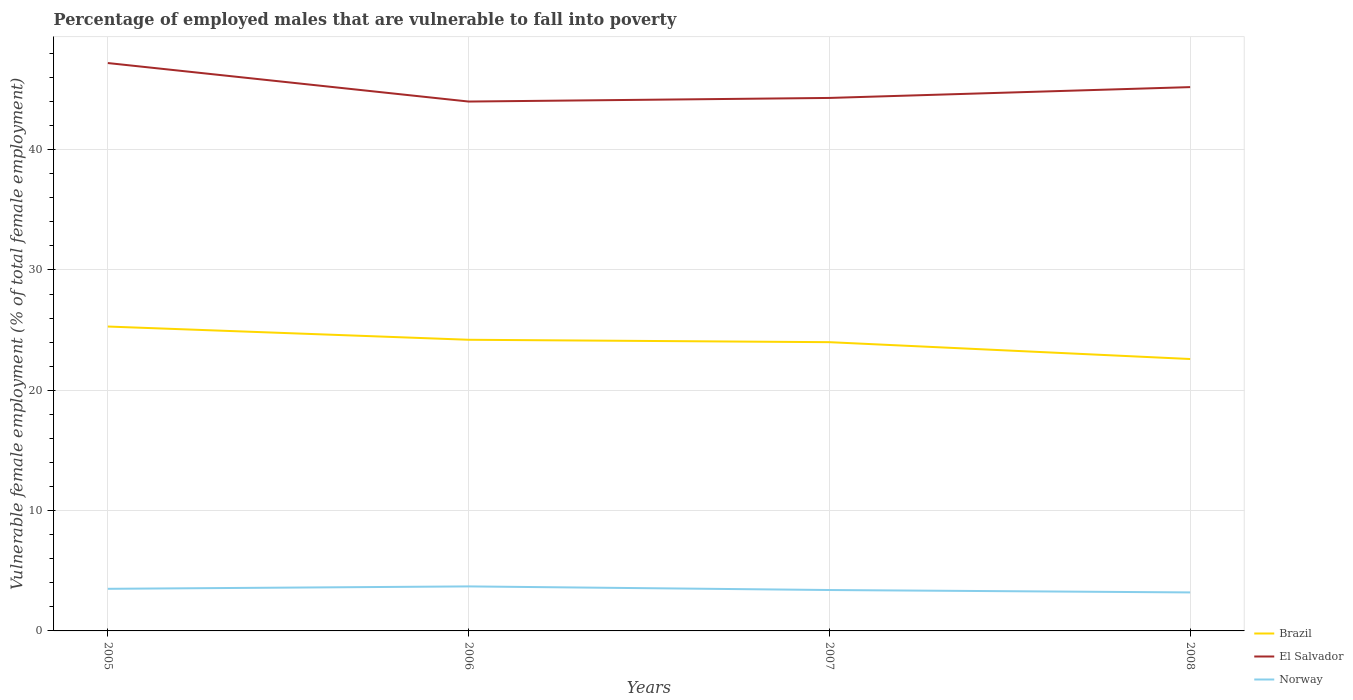How many different coloured lines are there?
Provide a short and direct response. 3. Is the number of lines equal to the number of legend labels?
Offer a very short reply. Yes. Across all years, what is the maximum percentage of employed males who are vulnerable to fall into poverty in Brazil?
Provide a succinct answer. 22.6. In which year was the percentage of employed males who are vulnerable to fall into poverty in Brazil maximum?
Provide a short and direct response. 2008. What is the total percentage of employed males who are vulnerable to fall into poverty in Brazil in the graph?
Your answer should be very brief. 1.6. What is the difference between the highest and the second highest percentage of employed males who are vulnerable to fall into poverty in Norway?
Offer a terse response. 0.5. What is the difference between the highest and the lowest percentage of employed males who are vulnerable to fall into poverty in El Salvador?
Your response must be concise. 2. Is the percentage of employed males who are vulnerable to fall into poverty in Brazil strictly greater than the percentage of employed males who are vulnerable to fall into poverty in Norway over the years?
Make the answer very short. No. How many lines are there?
Ensure brevity in your answer.  3. How many years are there in the graph?
Offer a terse response. 4. Does the graph contain any zero values?
Offer a very short reply. No. Does the graph contain grids?
Your answer should be very brief. Yes. How many legend labels are there?
Offer a terse response. 3. What is the title of the graph?
Your response must be concise. Percentage of employed males that are vulnerable to fall into poverty. Does "South Asia" appear as one of the legend labels in the graph?
Keep it short and to the point. No. What is the label or title of the X-axis?
Your answer should be compact. Years. What is the label or title of the Y-axis?
Your answer should be compact. Vulnerable female employment (% of total female employment). What is the Vulnerable female employment (% of total female employment) of Brazil in 2005?
Your answer should be compact. 25.3. What is the Vulnerable female employment (% of total female employment) in El Salvador in 2005?
Offer a very short reply. 47.2. What is the Vulnerable female employment (% of total female employment) of Brazil in 2006?
Provide a short and direct response. 24.2. What is the Vulnerable female employment (% of total female employment) of Norway in 2006?
Give a very brief answer. 3.7. What is the Vulnerable female employment (% of total female employment) of El Salvador in 2007?
Your response must be concise. 44.3. What is the Vulnerable female employment (% of total female employment) in Norway in 2007?
Keep it short and to the point. 3.4. What is the Vulnerable female employment (% of total female employment) of Brazil in 2008?
Provide a succinct answer. 22.6. What is the Vulnerable female employment (% of total female employment) of El Salvador in 2008?
Your answer should be compact. 45.2. What is the Vulnerable female employment (% of total female employment) of Norway in 2008?
Ensure brevity in your answer.  3.2. Across all years, what is the maximum Vulnerable female employment (% of total female employment) in Brazil?
Offer a terse response. 25.3. Across all years, what is the maximum Vulnerable female employment (% of total female employment) of El Salvador?
Your response must be concise. 47.2. Across all years, what is the maximum Vulnerable female employment (% of total female employment) of Norway?
Your answer should be compact. 3.7. Across all years, what is the minimum Vulnerable female employment (% of total female employment) of Brazil?
Provide a short and direct response. 22.6. Across all years, what is the minimum Vulnerable female employment (% of total female employment) of El Salvador?
Provide a succinct answer. 44. Across all years, what is the minimum Vulnerable female employment (% of total female employment) in Norway?
Offer a very short reply. 3.2. What is the total Vulnerable female employment (% of total female employment) of Brazil in the graph?
Ensure brevity in your answer.  96.1. What is the total Vulnerable female employment (% of total female employment) in El Salvador in the graph?
Keep it short and to the point. 180.7. What is the difference between the Vulnerable female employment (% of total female employment) in El Salvador in 2005 and that in 2006?
Give a very brief answer. 3.2. What is the difference between the Vulnerable female employment (% of total female employment) of Brazil in 2005 and that in 2007?
Keep it short and to the point. 1.3. What is the difference between the Vulnerable female employment (% of total female employment) in El Salvador in 2005 and that in 2007?
Provide a short and direct response. 2.9. What is the difference between the Vulnerable female employment (% of total female employment) of El Salvador in 2005 and that in 2008?
Keep it short and to the point. 2. What is the difference between the Vulnerable female employment (% of total female employment) in Brazil in 2006 and that in 2007?
Offer a terse response. 0.2. What is the difference between the Vulnerable female employment (% of total female employment) in Norway in 2006 and that in 2007?
Offer a very short reply. 0.3. What is the difference between the Vulnerable female employment (% of total female employment) of El Salvador in 2006 and that in 2008?
Your answer should be very brief. -1.2. What is the difference between the Vulnerable female employment (% of total female employment) of El Salvador in 2007 and that in 2008?
Offer a very short reply. -0.9. What is the difference between the Vulnerable female employment (% of total female employment) of Brazil in 2005 and the Vulnerable female employment (% of total female employment) of El Salvador in 2006?
Offer a very short reply. -18.7. What is the difference between the Vulnerable female employment (% of total female employment) of Brazil in 2005 and the Vulnerable female employment (% of total female employment) of Norway in 2006?
Keep it short and to the point. 21.6. What is the difference between the Vulnerable female employment (% of total female employment) of El Salvador in 2005 and the Vulnerable female employment (% of total female employment) of Norway in 2006?
Keep it short and to the point. 43.5. What is the difference between the Vulnerable female employment (% of total female employment) of Brazil in 2005 and the Vulnerable female employment (% of total female employment) of El Salvador in 2007?
Your answer should be compact. -19. What is the difference between the Vulnerable female employment (% of total female employment) of Brazil in 2005 and the Vulnerable female employment (% of total female employment) of Norway in 2007?
Ensure brevity in your answer.  21.9. What is the difference between the Vulnerable female employment (% of total female employment) of El Salvador in 2005 and the Vulnerable female employment (% of total female employment) of Norway in 2007?
Give a very brief answer. 43.8. What is the difference between the Vulnerable female employment (% of total female employment) of Brazil in 2005 and the Vulnerable female employment (% of total female employment) of El Salvador in 2008?
Make the answer very short. -19.9. What is the difference between the Vulnerable female employment (% of total female employment) in Brazil in 2005 and the Vulnerable female employment (% of total female employment) in Norway in 2008?
Keep it short and to the point. 22.1. What is the difference between the Vulnerable female employment (% of total female employment) in Brazil in 2006 and the Vulnerable female employment (% of total female employment) in El Salvador in 2007?
Provide a short and direct response. -20.1. What is the difference between the Vulnerable female employment (% of total female employment) in Brazil in 2006 and the Vulnerable female employment (% of total female employment) in Norway in 2007?
Your response must be concise. 20.8. What is the difference between the Vulnerable female employment (% of total female employment) in El Salvador in 2006 and the Vulnerable female employment (% of total female employment) in Norway in 2007?
Make the answer very short. 40.6. What is the difference between the Vulnerable female employment (% of total female employment) in El Salvador in 2006 and the Vulnerable female employment (% of total female employment) in Norway in 2008?
Offer a very short reply. 40.8. What is the difference between the Vulnerable female employment (% of total female employment) of Brazil in 2007 and the Vulnerable female employment (% of total female employment) of El Salvador in 2008?
Offer a terse response. -21.2. What is the difference between the Vulnerable female employment (% of total female employment) in Brazil in 2007 and the Vulnerable female employment (% of total female employment) in Norway in 2008?
Provide a short and direct response. 20.8. What is the difference between the Vulnerable female employment (% of total female employment) in El Salvador in 2007 and the Vulnerable female employment (% of total female employment) in Norway in 2008?
Give a very brief answer. 41.1. What is the average Vulnerable female employment (% of total female employment) of Brazil per year?
Your answer should be very brief. 24.02. What is the average Vulnerable female employment (% of total female employment) of El Salvador per year?
Offer a very short reply. 45.17. What is the average Vulnerable female employment (% of total female employment) of Norway per year?
Your response must be concise. 3.45. In the year 2005, what is the difference between the Vulnerable female employment (% of total female employment) in Brazil and Vulnerable female employment (% of total female employment) in El Salvador?
Keep it short and to the point. -21.9. In the year 2005, what is the difference between the Vulnerable female employment (% of total female employment) in Brazil and Vulnerable female employment (% of total female employment) in Norway?
Give a very brief answer. 21.8. In the year 2005, what is the difference between the Vulnerable female employment (% of total female employment) in El Salvador and Vulnerable female employment (% of total female employment) in Norway?
Keep it short and to the point. 43.7. In the year 2006, what is the difference between the Vulnerable female employment (% of total female employment) in Brazil and Vulnerable female employment (% of total female employment) in El Salvador?
Your answer should be very brief. -19.8. In the year 2006, what is the difference between the Vulnerable female employment (% of total female employment) in El Salvador and Vulnerable female employment (% of total female employment) in Norway?
Ensure brevity in your answer.  40.3. In the year 2007, what is the difference between the Vulnerable female employment (% of total female employment) in Brazil and Vulnerable female employment (% of total female employment) in El Salvador?
Provide a short and direct response. -20.3. In the year 2007, what is the difference between the Vulnerable female employment (% of total female employment) in Brazil and Vulnerable female employment (% of total female employment) in Norway?
Offer a terse response. 20.6. In the year 2007, what is the difference between the Vulnerable female employment (% of total female employment) in El Salvador and Vulnerable female employment (% of total female employment) in Norway?
Offer a terse response. 40.9. In the year 2008, what is the difference between the Vulnerable female employment (% of total female employment) in Brazil and Vulnerable female employment (% of total female employment) in El Salvador?
Provide a short and direct response. -22.6. What is the ratio of the Vulnerable female employment (% of total female employment) of Brazil in 2005 to that in 2006?
Offer a terse response. 1.05. What is the ratio of the Vulnerable female employment (% of total female employment) of El Salvador in 2005 to that in 2006?
Your response must be concise. 1.07. What is the ratio of the Vulnerable female employment (% of total female employment) of Norway in 2005 to that in 2006?
Offer a terse response. 0.95. What is the ratio of the Vulnerable female employment (% of total female employment) in Brazil in 2005 to that in 2007?
Your answer should be very brief. 1.05. What is the ratio of the Vulnerable female employment (% of total female employment) in El Salvador in 2005 to that in 2007?
Make the answer very short. 1.07. What is the ratio of the Vulnerable female employment (% of total female employment) of Norway in 2005 to that in 2007?
Your answer should be very brief. 1.03. What is the ratio of the Vulnerable female employment (% of total female employment) in Brazil in 2005 to that in 2008?
Offer a terse response. 1.12. What is the ratio of the Vulnerable female employment (% of total female employment) of El Salvador in 2005 to that in 2008?
Your response must be concise. 1.04. What is the ratio of the Vulnerable female employment (% of total female employment) in Norway in 2005 to that in 2008?
Your response must be concise. 1.09. What is the ratio of the Vulnerable female employment (% of total female employment) of Brazil in 2006 to that in 2007?
Provide a short and direct response. 1.01. What is the ratio of the Vulnerable female employment (% of total female employment) in Norway in 2006 to that in 2007?
Ensure brevity in your answer.  1.09. What is the ratio of the Vulnerable female employment (% of total female employment) in Brazil in 2006 to that in 2008?
Offer a very short reply. 1.07. What is the ratio of the Vulnerable female employment (% of total female employment) of El Salvador in 2006 to that in 2008?
Keep it short and to the point. 0.97. What is the ratio of the Vulnerable female employment (% of total female employment) of Norway in 2006 to that in 2008?
Make the answer very short. 1.16. What is the ratio of the Vulnerable female employment (% of total female employment) of Brazil in 2007 to that in 2008?
Your response must be concise. 1.06. What is the ratio of the Vulnerable female employment (% of total female employment) in El Salvador in 2007 to that in 2008?
Give a very brief answer. 0.98. What is the difference between the highest and the second highest Vulnerable female employment (% of total female employment) in El Salvador?
Make the answer very short. 2. What is the difference between the highest and the lowest Vulnerable female employment (% of total female employment) in Norway?
Your answer should be compact. 0.5. 